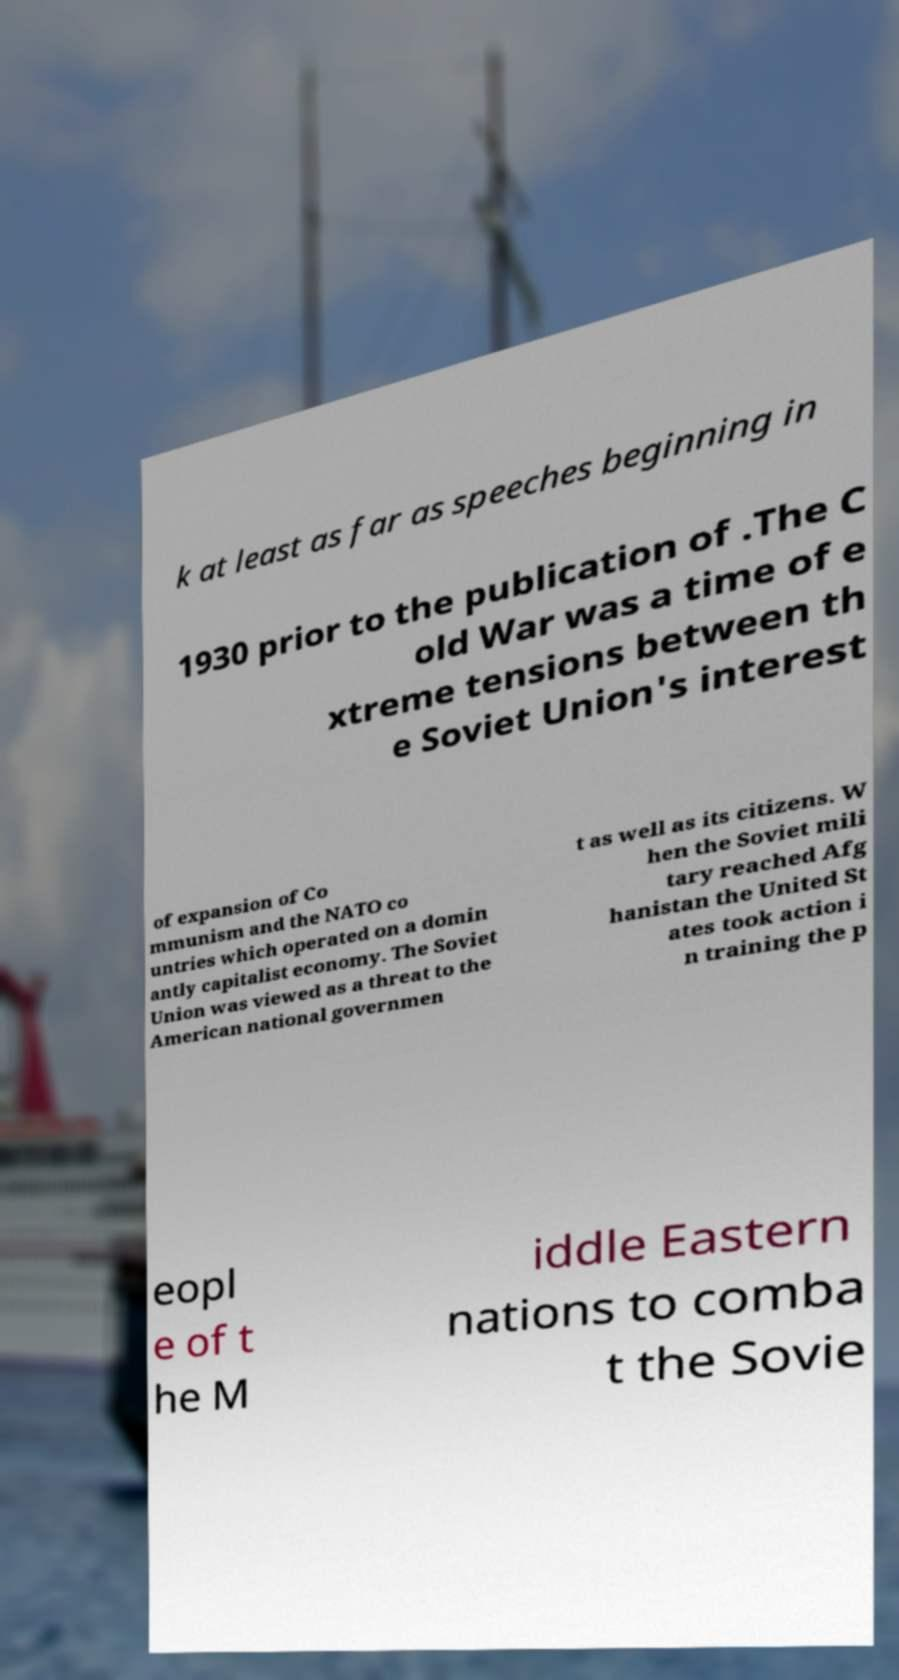There's text embedded in this image that I need extracted. Can you transcribe it verbatim? k at least as far as speeches beginning in 1930 prior to the publication of .The C old War was a time of e xtreme tensions between th e Soviet Union's interest of expansion of Co mmunism and the NATO co untries which operated on a domin antly capitalist economy. The Soviet Union was viewed as a threat to the American national governmen t as well as its citizens. W hen the Soviet mili tary reached Afg hanistan the United St ates took action i n training the p eopl e of t he M iddle Eastern nations to comba t the Sovie 